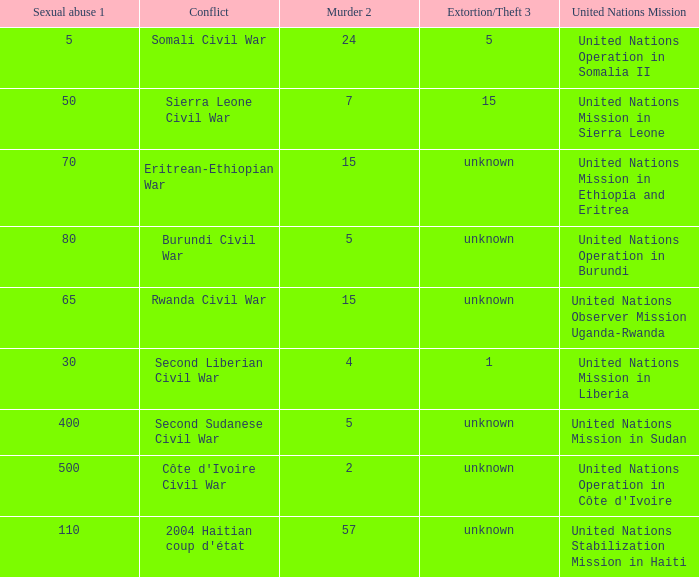Can you give me this table as a dict? {'header': ['Sexual abuse 1', 'Conflict', 'Murder 2', 'Extortion/Theft 3', 'United Nations Mission'], 'rows': [['5', 'Somali Civil War', '24', '5', 'United Nations Operation in Somalia II'], ['50', 'Sierra Leone Civil War', '7', '15', 'United Nations Mission in Sierra Leone'], ['70', 'Eritrean-Ethiopian War', '15', 'unknown', 'United Nations Mission in Ethiopia and Eritrea'], ['80', 'Burundi Civil War', '5', 'unknown', 'United Nations Operation in Burundi'], ['65', 'Rwanda Civil War', '15', 'unknown', 'United Nations Observer Mission Uganda-Rwanda'], ['30', 'Second Liberian Civil War', '4', '1', 'United Nations Mission in Liberia'], ['400', 'Second Sudanese Civil War', '5', 'unknown', 'United Nations Mission in Sudan'], ['500', "Côte d'Ivoire Civil War", '2', 'unknown', "United Nations Operation in Côte d'Ivoire"], ['110', "2004 Haitian coup d'état", '57', 'unknown', 'United Nations Stabilization Mission in Haiti']]} What is the sexual abuse rate where the conflict is the Second Sudanese Civil War? 400.0. 